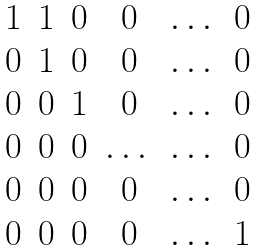Convert formula to latex. <formula><loc_0><loc_0><loc_500><loc_500>\begin{matrix} 1 & 1 & 0 & 0 & \dots & 0 \\ 0 & 1 & 0 & 0 & \dots & 0 \\ 0 & 0 & 1 & 0 & \dots & 0 \\ 0 & 0 & 0 & \dots & \dots & 0 \\ 0 & 0 & 0 & 0 & \dots & 0 \\ 0 & 0 & 0 & 0 & \dots & 1 \\ \end{matrix}</formula> 